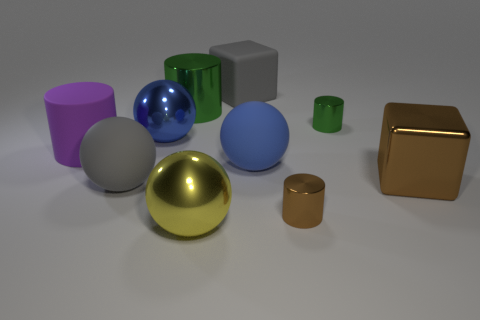How many things are tiny purple metal cylinders or big metal objects that are left of the yellow metallic object?
Give a very brief answer. 2. There is a metal ball that is in front of the big brown metallic thing; is there a big gray block behind it?
Offer a very short reply. Yes. There is a green thing on the right side of the tiny thing in front of the large blue ball behind the purple thing; what shape is it?
Give a very brief answer. Cylinder. There is a big sphere that is both to the left of the big green shiny cylinder and in front of the big blue metal object; what is its color?
Provide a short and direct response. Gray. There is a blue thing that is to the left of the big yellow sphere; what shape is it?
Offer a terse response. Sphere. What shape is the blue thing that is made of the same material as the purple cylinder?
Make the answer very short. Sphere. How many matte things are big yellow balls or large cylinders?
Your answer should be compact. 1. There is a large sphere to the right of the metallic ball in front of the blue metal sphere; what number of brown objects are in front of it?
Ensure brevity in your answer.  2. There is a green cylinder to the left of the small green metal cylinder; does it have the same size as the gray object that is left of the yellow metallic sphere?
Your response must be concise. Yes. There is another big object that is the same shape as the big brown shiny object; what material is it?
Keep it short and to the point. Rubber. 